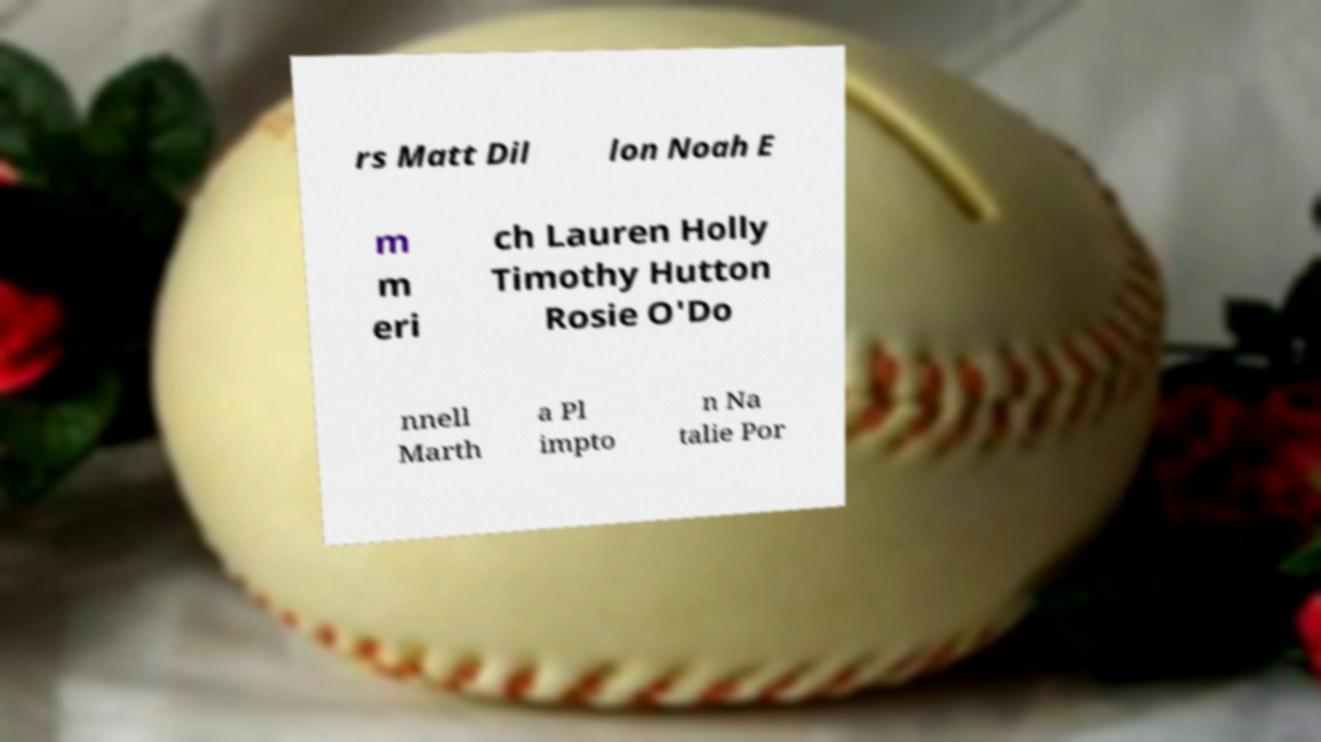Please read and relay the text visible in this image. What does it say? rs Matt Dil lon Noah E m m eri ch Lauren Holly Timothy Hutton Rosie O'Do nnell Marth a Pl impto n Na talie Por 